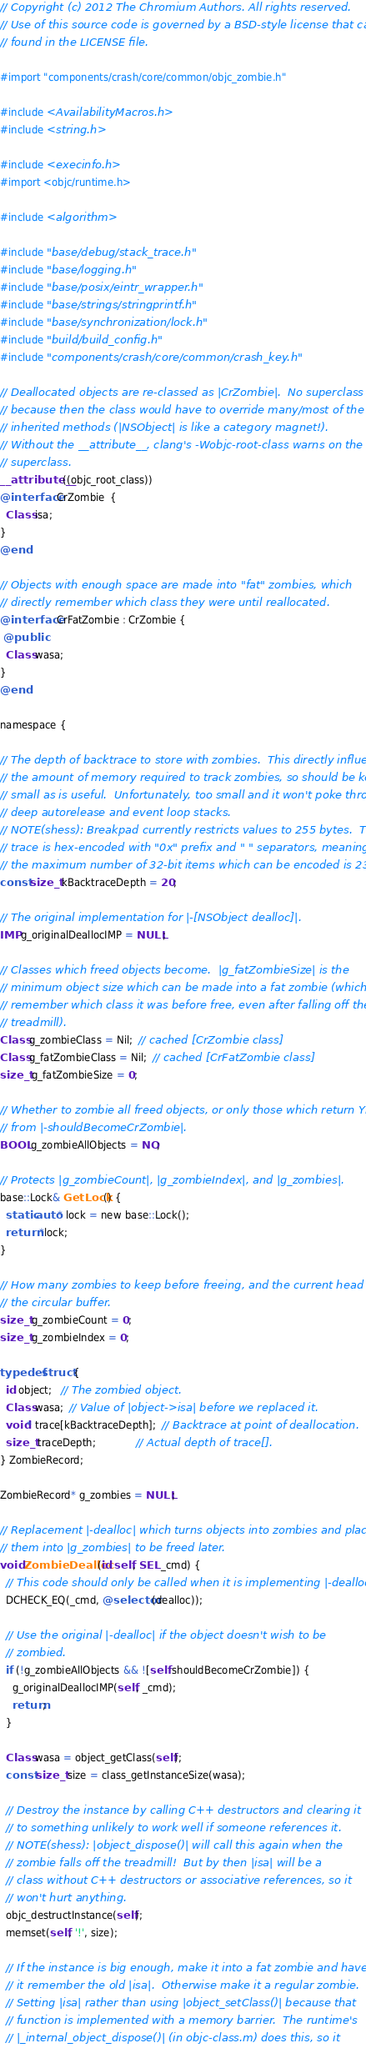<code> <loc_0><loc_0><loc_500><loc_500><_ObjectiveC_>// Copyright (c) 2012 The Chromium Authors. All rights reserved.
// Use of this source code is governed by a BSD-style license that can be
// found in the LICENSE file.

#import "components/crash/core/common/objc_zombie.h"

#include <AvailabilityMacros.h>
#include <string.h>

#include <execinfo.h>
#import <objc/runtime.h>

#include <algorithm>

#include "base/debug/stack_trace.h"
#include "base/logging.h"
#include "base/posix/eintr_wrapper.h"
#include "base/strings/stringprintf.h"
#include "base/synchronization/lock.h"
#include "build/build_config.h"
#include "components/crash/core/common/crash_key.h"

// Deallocated objects are re-classed as |CrZombie|.  No superclass
// because then the class would have to override many/most of the
// inherited methods (|NSObject| is like a category magnet!).
// Without the __attribute__, clang's -Wobjc-root-class warns on the missing
// superclass.
__attribute__((objc_root_class))
@interface CrZombie  {
  Class isa;
}
@end

// Objects with enough space are made into "fat" zombies, which
// directly remember which class they were until reallocated.
@interface CrFatZombie : CrZombie {
 @public
  Class wasa;
}
@end

namespace {

// The depth of backtrace to store with zombies.  This directly influences
// the amount of memory required to track zombies, so should be kept as
// small as is useful.  Unfortunately, too small and it won't poke through
// deep autorelease and event loop stacks.
// NOTE(shess): Breakpad currently restricts values to 255 bytes.  The
// trace is hex-encoded with "0x" prefix and " " separators, meaning
// the maximum number of 32-bit items which can be encoded is 23.
const size_t kBacktraceDepth = 20;

// The original implementation for |-[NSObject dealloc]|.
IMP g_originalDeallocIMP = NULL;

// Classes which freed objects become.  |g_fatZombieSize| is the
// minimum object size which can be made into a fat zombie (which can
// remember which class it was before free, even after falling off the
// treadmill).
Class g_zombieClass = Nil;  // cached [CrZombie class]
Class g_fatZombieClass = Nil;  // cached [CrFatZombie class]
size_t g_fatZombieSize = 0;

// Whether to zombie all freed objects, or only those which return YES
// from |-shouldBecomeCrZombie|.
BOOL g_zombieAllObjects = NO;

// Protects |g_zombieCount|, |g_zombieIndex|, and |g_zombies|.
base::Lock& GetLock() {
  static auto* lock = new base::Lock();
  return *lock;
}

// How many zombies to keep before freeing, and the current head of
// the circular buffer.
size_t g_zombieCount = 0;
size_t g_zombieIndex = 0;

typedef struct {
  id object;   // The zombied object.
  Class wasa;  // Value of |object->isa| before we replaced it.
  void* trace[kBacktraceDepth];  // Backtrace at point of deallocation.
  size_t traceDepth;             // Actual depth of trace[].
} ZombieRecord;

ZombieRecord* g_zombies = NULL;

// Replacement |-dealloc| which turns objects into zombies and places
// them into |g_zombies| to be freed later.
void ZombieDealloc(id self, SEL _cmd) {
  // This code should only be called when it is implementing |-dealloc|.
  DCHECK_EQ(_cmd, @selector(dealloc));

  // Use the original |-dealloc| if the object doesn't wish to be
  // zombied.
  if (!g_zombieAllObjects && ![self shouldBecomeCrZombie]) {
    g_originalDeallocIMP(self, _cmd);
    return;
  }

  Class wasa = object_getClass(self);
  const size_t size = class_getInstanceSize(wasa);

  // Destroy the instance by calling C++ destructors and clearing it
  // to something unlikely to work well if someone references it.
  // NOTE(shess): |object_dispose()| will call this again when the
  // zombie falls off the treadmill!  But by then |isa| will be a
  // class without C++ destructors or associative references, so it
  // won't hurt anything.
  objc_destructInstance(self);
  memset(self, '!', size);

  // If the instance is big enough, make it into a fat zombie and have
  // it remember the old |isa|.  Otherwise make it a regular zombie.
  // Setting |isa| rather than using |object_setClass()| because that
  // function is implemented with a memory barrier.  The runtime's
  // |_internal_object_dispose()| (in objc-class.m) does this, so it</code> 